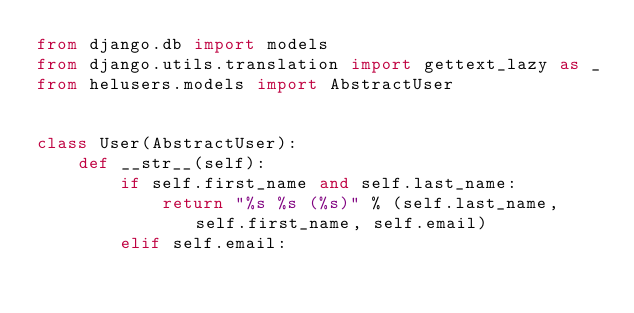<code> <loc_0><loc_0><loc_500><loc_500><_Python_>from django.db import models
from django.utils.translation import gettext_lazy as _
from helusers.models import AbstractUser


class User(AbstractUser):
    def __str__(self):
        if self.first_name and self.last_name:
            return "%s %s (%s)" % (self.last_name, self.first_name, self.email)
        elif self.email:</code> 